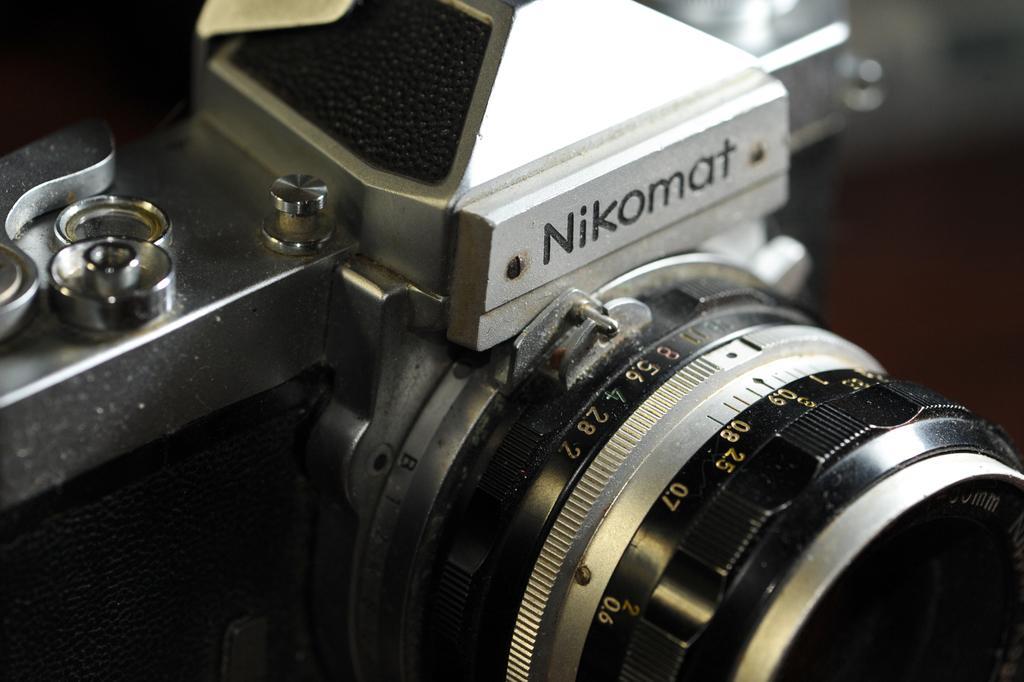In one or two sentences, can you explain what this image depicts? In this picture I can see the camera. 